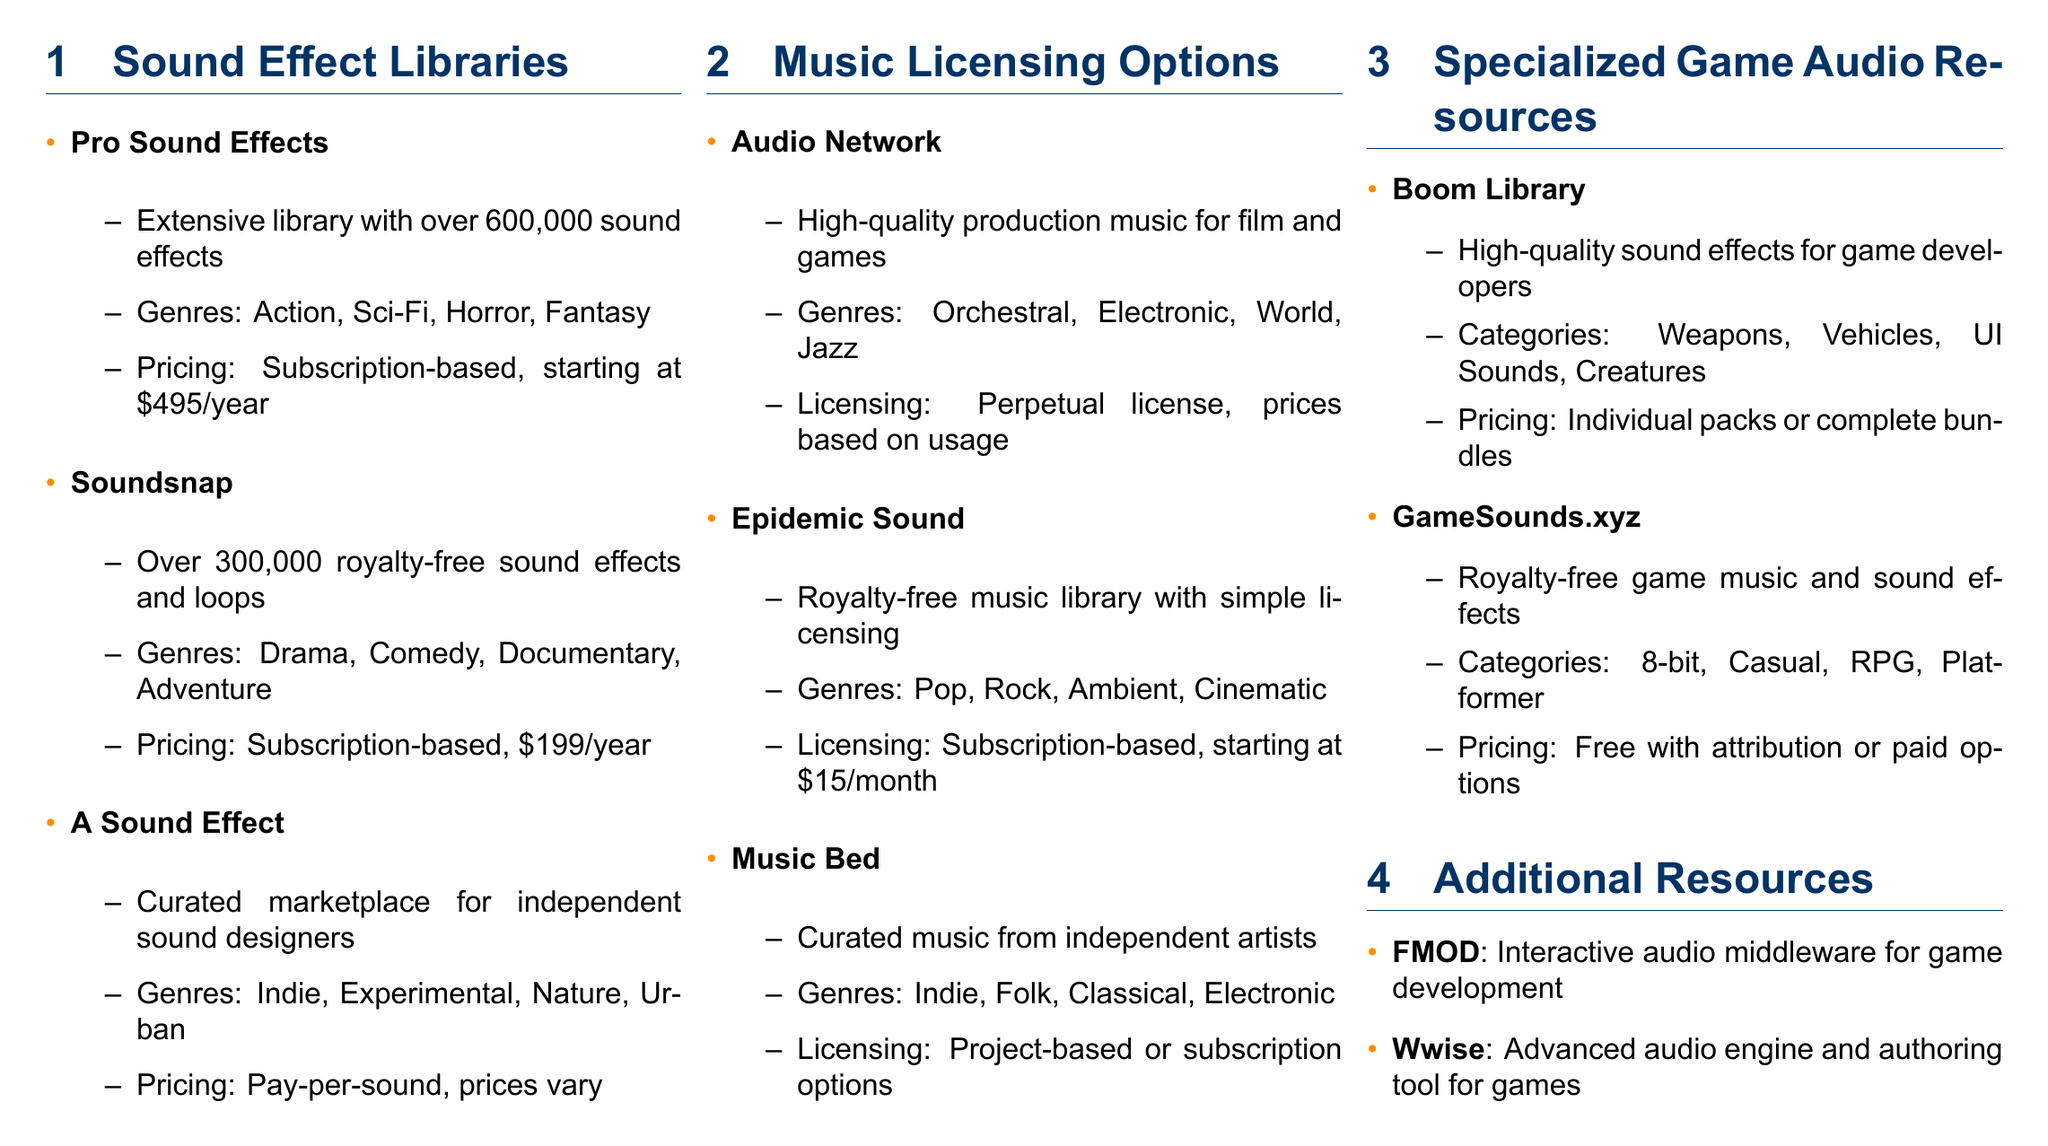What library offers over 600,000 sound effects? The document states that Pro Sound Effects has an extensive library with over 600,000 sound effects.
Answer: Pro Sound Effects What is the starting price for Epidemic Sound? The document mentions that Epidemic Sound has a subscription starting at \$15/month.
Answer: \$15/month Which music licensing option offers curated music from independent artists? The document indicates that Music Bed provides curated music from independent artists.
Answer: Music Bed What is the genre of sound effects available from Soundsnap? According to the document, Soundsnap offers genres like Drama, Comedy, Documentary, and Adventure.
Answer: Drama, Comedy, Documentary, Adventure What kind of license does Audio Network offer? The document explains that Audio Network provides a perpetual license, with prices based on usage.
Answer: Perpetual license How many categories of sound effects does Boom Library specialize in? The document notes that Boom Library specializes in categories such as Weapons, Vehicles, UI Sounds, and Creatures.
Answer: Four categories What is the pricing model for A Sound Effect? The document states that A Sound Effect uses a pay-per-sound pricing model where prices vary.
Answer: Pay-per-sound What type of products does GameSounds.xyz provide? The document describes GameSounds.xyz as offering royalty-free game music and sound effects.
Answer: Royalty-free game music and sound effects What does Wwise provide? The document indicates that Wwise is an advanced audio engine and authoring tool for games.
Answer: Advanced audio engine and authoring tool 